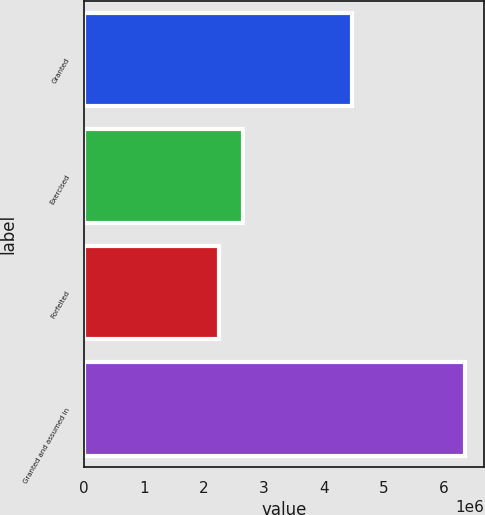<chart> <loc_0><loc_0><loc_500><loc_500><bar_chart><fcel>Granted<fcel>Exercised<fcel>Forfeited<fcel>Granted and assumed in<nl><fcel>4.456e+06<fcel>2.6496e+06<fcel>2.239e+06<fcel>6.345e+06<nl></chart> 